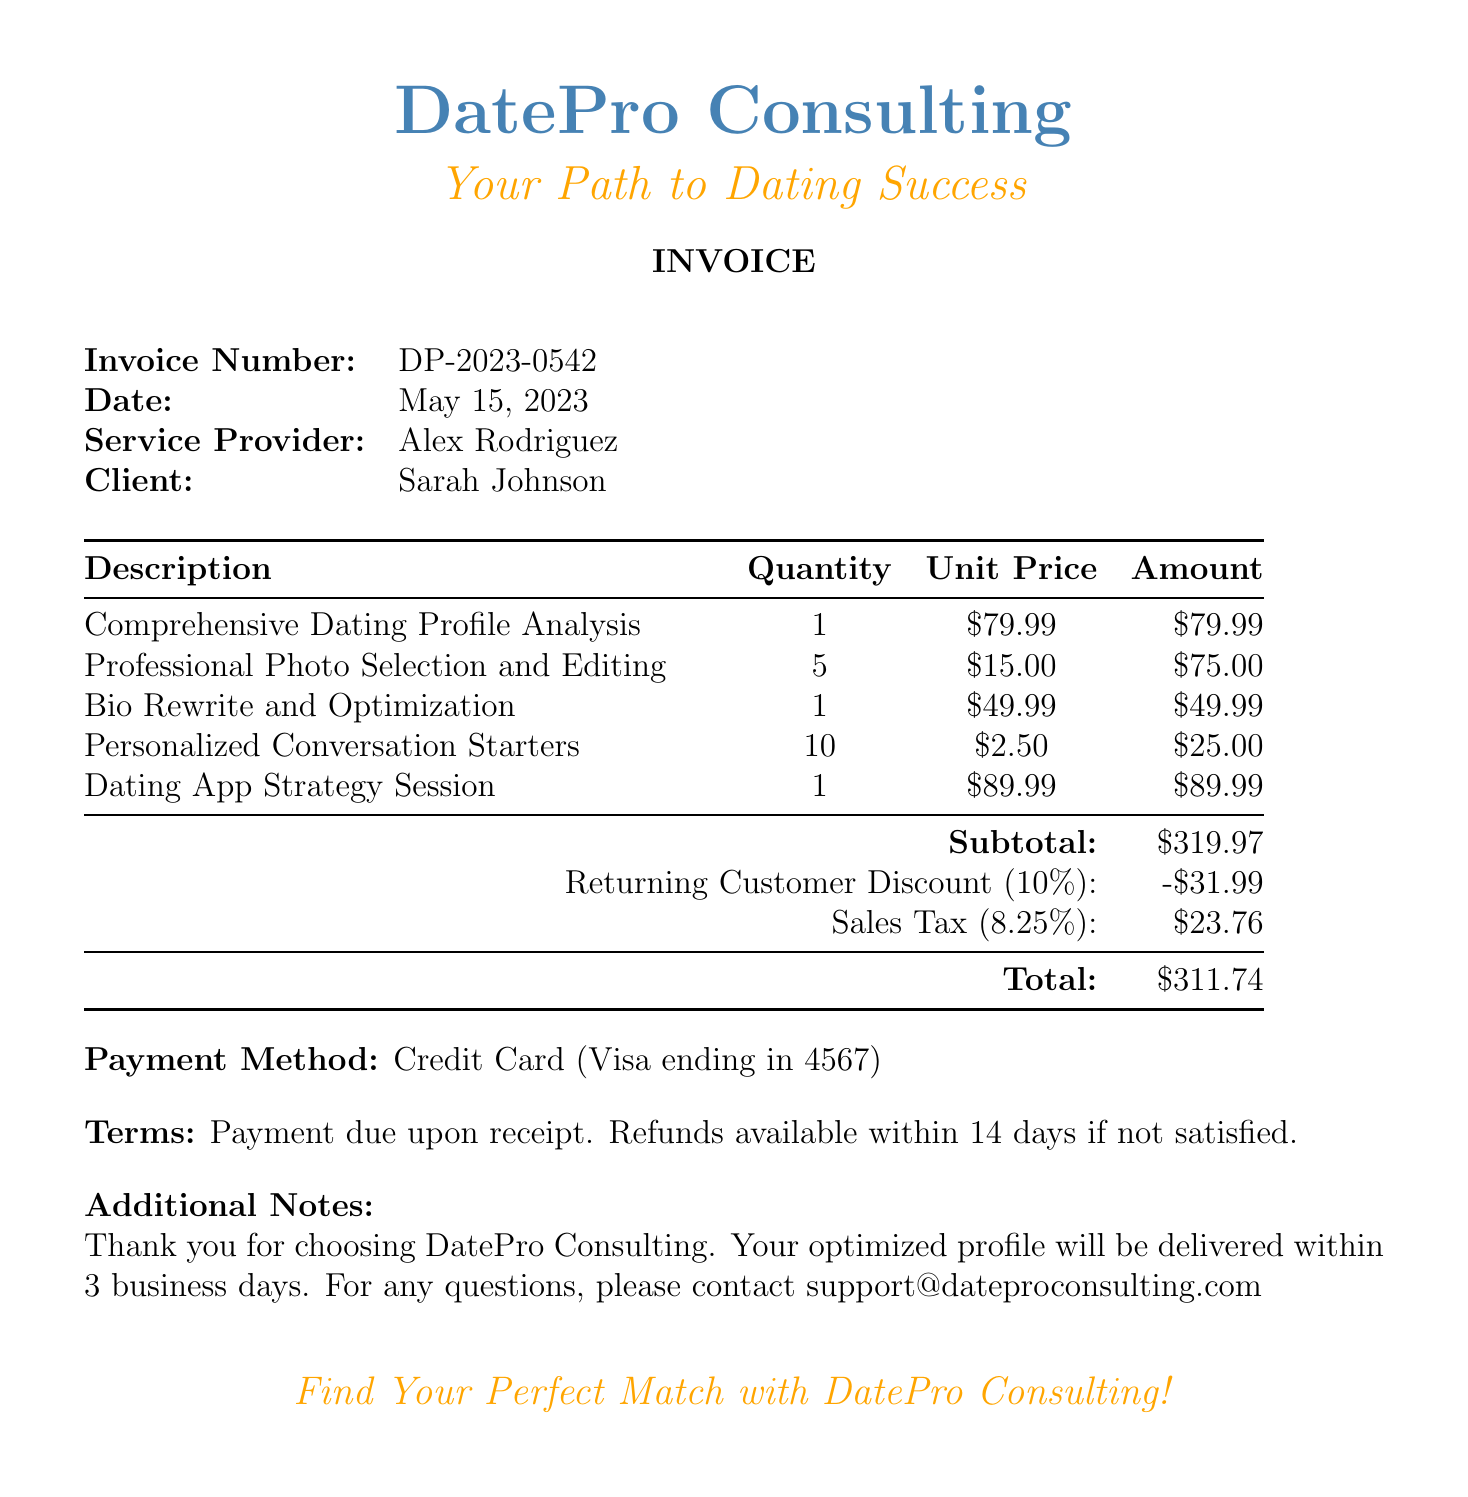What is the name of the service provider? The name of the service provider is listed in the document under the service provider section.
Answer: Alex Rodriguez What is the total amount due? The total amount is specified at the bottom of the invoice as the final amount to be paid.
Answer: $311.74 When was the invoice issued? The date of the invoice is clearly mentioned in the document.
Answer: May 15, 2023 How many professional photos were selected and edited? The quantity of professional photos is specified in the services section of the document.
Answer: 5 What discount was applied to the invoice? The document describes a discount applied to the subtotal, indicating the type and percentage.
Answer: Returning Customer Discount (10%) What is the subtotal before taxes and discounts? The subtotal is listed in the invoice prior to any discounts or taxes being applied.
Answer: $319.97 What is the payment method used? The payment method is indicated in a dedicated section of the invoice.
Answer: Credit Card (Visa ending in 4567) How long will it take to deliver the optimized profile? This information is mentioned in the additional notes at the end of the document.
Answer: Within 3 business days What is the invoice number? The invoice number is specified at the top of the document.
Answer: DP-2023-0542 